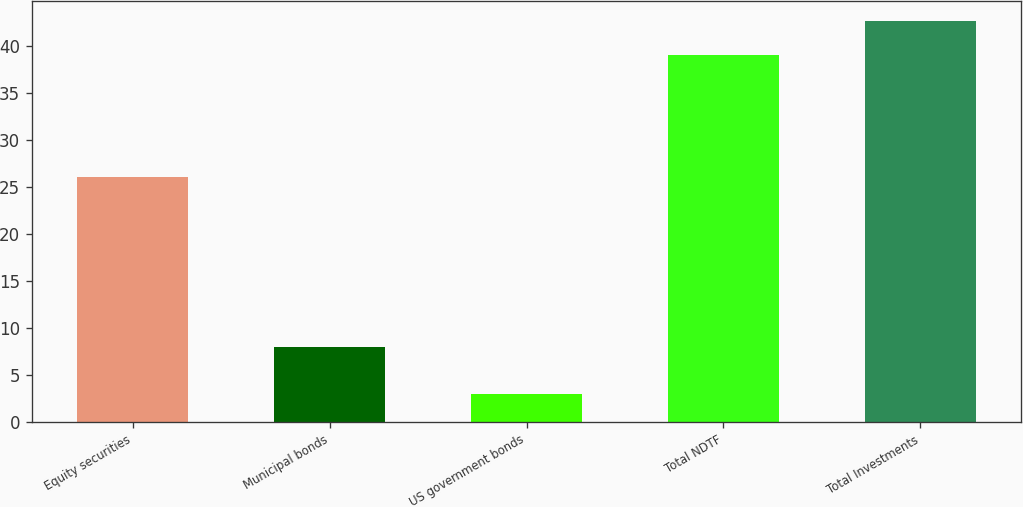<chart> <loc_0><loc_0><loc_500><loc_500><bar_chart><fcel>Equity securities<fcel>Municipal bonds<fcel>US government bonds<fcel>Total NDTF<fcel>Total Investments<nl><fcel>26<fcel>8<fcel>3<fcel>39<fcel>42.6<nl></chart> 